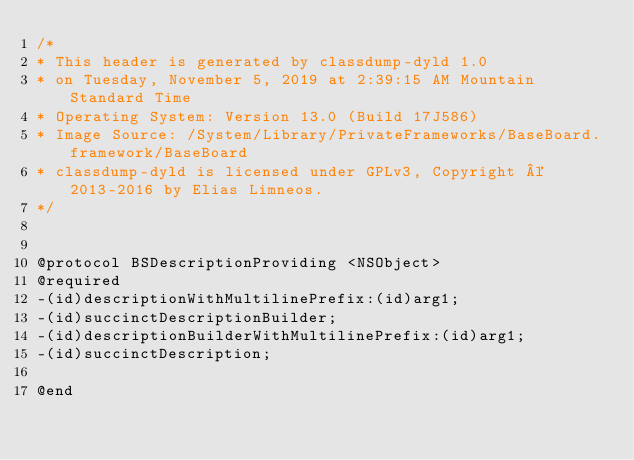Convert code to text. <code><loc_0><loc_0><loc_500><loc_500><_C_>/*
* This header is generated by classdump-dyld 1.0
* on Tuesday, November 5, 2019 at 2:39:15 AM Mountain Standard Time
* Operating System: Version 13.0 (Build 17J586)
* Image Source: /System/Library/PrivateFrameworks/BaseBoard.framework/BaseBoard
* classdump-dyld is licensed under GPLv3, Copyright © 2013-2016 by Elias Limneos.
*/


@protocol BSDescriptionProviding <NSObject>
@required
-(id)descriptionWithMultilinePrefix:(id)arg1;
-(id)succinctDescriptionBuilder;
-(id)descriptionBuilderWithMultilinePrefix:(id)arg1;
-(id)succinctDescription;

@end

</code> 